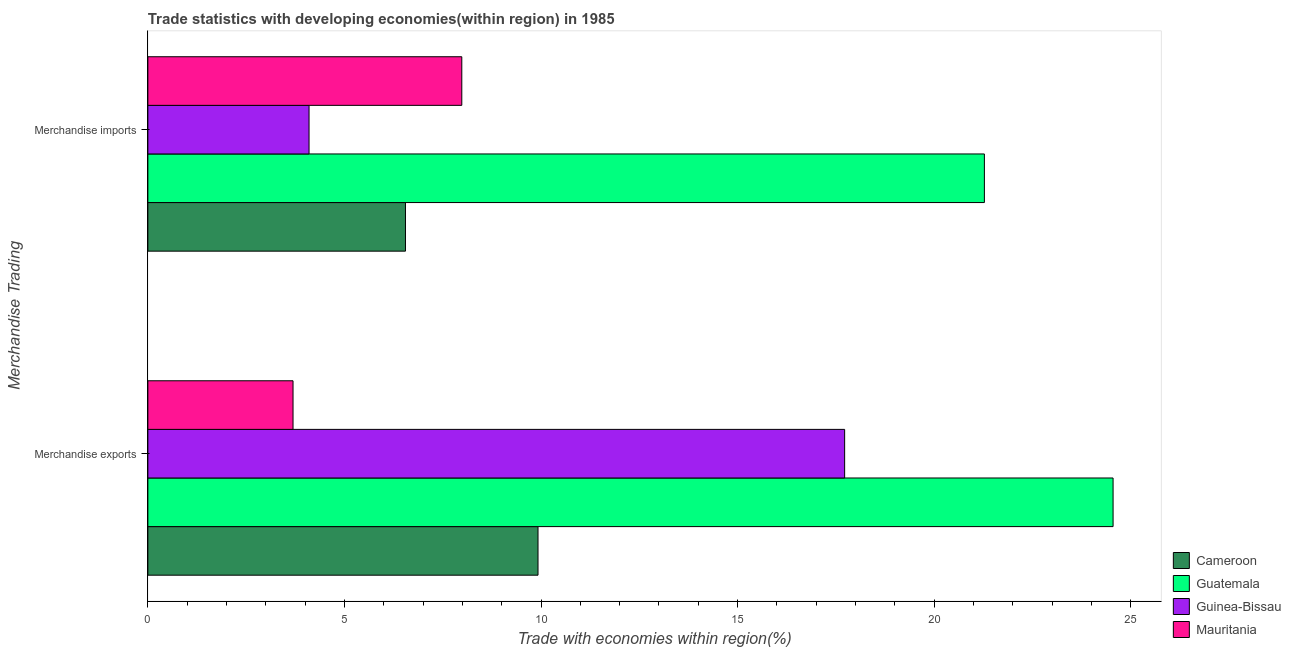How many different coloured bars are there?
Give a very brief answer. 4. How many groups of bars are there?
Your answer should be compact. 2. What is the label of the 1st group of bars from the top?
Make the answer very short. Merchandise imports. What is the merchandise imports in Mauritania?
Your answer should be very brief. 7.98. Across all countries, what is the maximum merchandise imports?
Keep it short and to the point. 21.28. Across all countries, what is the minimum merchandise exports?
Your answer should be compact. 3.69. In which country was the merchandise imports maximum?
Provide a short and direct response. Guatemala. In which country was the merchandise imports minimum?
Make the answer very short. Guinea-Bissau. What is the total merchandise imports in the graph?
Ensure brevity in your answer.  39.91. What is the difference between the merchandise imports in Cameroon and that in Guinea-Bissau?
Provide a succinct answer. 2.45. What is the difference between the merchandise imports in Mauritania and the merchandise exports in Guinea-Bissau?
Ensure brevity in your answer.  -9.74. What is the average merchandise imports per country?
Your answer should be very brief. 9.98. What is the difference between the merchandise exports and merchandise imports in Guinea-Bissau?
Keep it short and to the point. 13.62. In how many countries, is the merchandise imports greater than 13 %?
Ensure brevity in your answer.  1. What is the ratio of the merchandise exports in Guinea-Bissau to that in Guatemala?
Give a very brief answer. 0.72. In how many countries, is the merchandise imports greater than the average merchandise imports taken over all countries?
Your answer should be compact. 1. What does the 3rd bar from the top in Merchandise exports represents?
Give a very brief answer. Guatemala. What does the 2nd bar from the bottom in Merchandise exports represents?
Provide a short and direct response. Guatemala. How many bars are there?
Your answer should be very brief. 8. Are all the bars in the graph horizontal?
Give a very brief answer. Yes. What is the difference between two consecutive major ticks on the X-axis?
Your answer should be very brief. 5. Does the graph contain grids?
Make the answer very short. No. How many legend labels are there?
Offer a terse response. 4. How are the legend labels stacked?
Keep it short and to the point. Vertical. What is the title of the graph?
Offer a very short reply. Trade statistics with developing economies(within region) in 1985. Does "Malaysia" appear as one of the legend labels in the graph?
Keep it short and to the point. No. What is the label or title of the X-axis?
Provide a short and direct response. Trade with economies within region(%). What is the label or title of the Y-axis?
Offer a very short reply. Merchandise Trading. What is the Trade with economies within region(%) of Cameroon in Merchandise exports?
Provide a short and direct response. 9.92. What is the Trade with economies within region(%) of Guatemala in Merchandise exports?
Ensure brevity in your answer.  24.55. What is the Trade with economies within region(%) in Guinea-Bissau in Merchandise exports?
Ensure brevity in your answer.  17.72. What is the Trade with economies within region(%) of Mauritania in Merchandise exports?
Your answer should be compact. 3.69. What is the Trade with economies within region(%) in Cameroon in Merchandise imports?
Your answer should be compact. 6.55. What is the Trade with economies within region(%) of Guatemala in Merchandise imports?
Give a very brief answer. 21.28. What is the Trade with economies within region(%) in Guinea-Bissau in Merchandise imports?
Offer a terse response. 4.1. What is the Trade with economies within region(%) of Mauritania in Merchandise imports?
Give a very brief answer. 7.98. Across all Merchandise Trading, what is the maximum Trade with economies within region(%) of Cameroon?
Make the answer very short. 9.92. Across all Merchandise Trading, what is the maximum Trade with economies within region(%) of Guatemala?
Your answer should be very brief. 24.55. Across all Merchandise Trading, what is the maximum Trade with economies within region(%) in Guinea-Bissau?
Offer a very short reply. 17.72. Across all Merchandise Trading, what is the maximum Trade with economies within region(%) in Mauritania?
Provide a succinct answer. 7.98. Across all Merchandise Trading, what is the minimum Trade with economies within region(%) of Cameroon?
Your answer should be very brief. 6.55. Across all Merchandise Trading, what is the minimum Trade with economies within region(%) in Guatemala?
Make the answer very short. 21.28. Across all Merchandise Trading, what is the minimum Trade with economies within region(%) of Guinea-Bissau?
Offer a terse response. 4.1. Across all Merchandise Trading, what is the minimum Trade with economies within region(%) of Mauritania?
Your response must be concise. 3.69. What is the total Trade with economies within region(%) in Cameroon in the graph?
Offer a very short reply. 16.48. What is the total Trade with economies within region(%) of Guatemala in the graph?
Your answer should be very brief. 45.83. What is the total Trade with economies within region(%) of Guinea-Bissau in the graph?
Give a very brief answer. 21.82. What is the total Trade with economies within region(%) in Mauritania in the graph?
Your answer should be compact. 11.68. What is the difference between the Trade with economies within region(%) of Cameroon in Merchandise exports and that in Merchandise imports?
Offer a very short reply. 3.37. What is the difference between the Trade with economies within region(%) in Guatemala in Merchandise exports and that in Merchandise imports?
Give a very brief answer. 3.27. What is the difference between the Trade with economies within region(%) in Guinea-Bissau in Merchandise exports and that in Merchandise imports?
Make the answer very short. 13.62. What is the difference between the Trade with economies within region(%) in Mauritania in Merchandise exports and that in Merchandise imports?
Keep it short and to the point. -4.29. What is the difference between the Trade with economies within region(%) of Cameroon in Merchandise exports and the Trade with economies within region(%) of Guatemala in Merchandise imports?
Your response must be concise. -11.35. What is the difference between the Trade with economies within region(%) in Cameroon in Merchandise exports and the Trade with economies within region(%) in Guinea-Bissau in Merchandise imports?
Your answer should be very brief. 5.82. What is the difference between the Trade with economies within region(%) of Cameroon in Merchandise exports and the Trade with economies within region(%) of Mauritania in Merchandise imports?
Keep it short and to the point. 1.94. What is the difference between the Trade with economies within region(%) in Guatemala in Merchandise exports and the Trade with economies within region(%) in Guinea-Bissau in Merchandise imports?
Your answer should be compact. 20.45. What is the difference between the Trade with economies within region(%) in Guatemala in Merchandise exports and the Trade with economies within region(%) in Mauritania in Merchandise imports?
Give a very brief answer. 16.57. What is the difference between the Trade with economies within region(%) in Guinea-Bissau in Merchandise exports and the Trade with economies within region(%) in Mauritania in Merchandise imports?
Your response must be concise. 9.74. What is the average Trade with economies within region(%) of Cameroon per Merchandise Trading?
Give a very brief answer. 8.24. What is the average Trade with economies within region(%) in Guatemala per Merchandise Trading?
Offer a terse response. 22.91. What is the average Trade with economies within region(%) in Guinea-Bissau per Merchandise Trading?
Give a very brief answer. 10.91. What is the average Trade with economies within region(%) in Mauritania per Merchandise Trading?
Offer a very short reply. 5.84. What is the difference between the Trade with economies within region(%) of Cameroon and Trade with economies within region(%) of Guatemala in Merchandise exports?
Your answer should be compact. -14.63. What is the difference between the Trade with economies within region(%) in Cameroon and Trade with economies within region(%) in Guinea-Bissau in Merchandise exports?
Your response must be concise. -7.8. What is the difference between the Trade with economies within region(%) of Cameroon and Trade with economies within region(%) of Mauritania in Merchandise exports?
Your answer should be compact. 6.23. What is the difference between the Trade with economies within region(%) in Guatemala and Trade with economies within region(%) in Guinea-Bissau in Merchandise exports?
Make the answer very short. 6.83. What is the difference between the Trade with economies within region(%) in Guatemala and Trade with economies within region(%) in Mauritania in Merchandise exports?
Your answer should be very brief. 20.86. What is the difference between the Trade with economies within region(%) of Guinea-Bissau and Trade with economies within region(%) of Mauritania in Merchandise exports?
Give a very brief answer. 14.03. What is the difference between the Trade with economies within region(%) of Cameroon and Trade with economies within region(%) of Guatemala in Merchandise imports?
Keep it short and to the point. -14.73. What is the difference between the Trade with economies within region(%) of Cameroon and Trade with economies within region(%) of Guinea-Bissau in Merchandise imports?
Ensure brevity in your answer.  2.45. What is the difference between the Trade with economies within region(%) in Cameroon and Trade with economies within region(%) in Mauritania in Merchandise imports?
Ensure brevity in your answer.  -1.43. What is the difference between the Trade with economies within region(%) of Guatemala and Trade with economies within region(%) of Guinea-Bissau in Merchandise imports?
Provide a succinct answer. 17.18. What is the difference between the Trade with economies within region(%) in Guatemala and Trade with economies within region(%) in Mauritania in Merchandise imports?
Your response must be concise. 13.29. What is the difference between the Trade with economies within region(%) in Guinea-Bissau and Trade with economies within region(%) in Mauritania in Merchandise imports?
Make the answer very short. -3.89. What is the ratio of the Trade with economies within region(%) in Cameroon in Merchandise exports to that in Merchandise imports?
Give a very brief answer. 1.51. What is the ratio of the Trade with economies within region(%) in Guatemala in Merchandise exports to that in Merchandise imports?
Ensure brevity in your answer.  1.15. What is the ratio of the Trade with economies within region(%) in Guinea-Bissau in Merchandise exports to that in Merchandise imports?
Keep it short and to the point. 4.32. What is the ratio of the Trade with economies within region(%) in Mauritania in Merchandise exports to that in Merchandise imports?
Give a very brief answer. 0.46. What is the difference between the highest and the second highest Trade with economies within region(%) in Cameroon?
Ensure brevity in your answer.  3.37. What is the difference between the highest and the second highest Trade with economies within region(%) of Guatemala?
Provide a short and direct response. 3.27. What is the difference between the highest and the second highest Trade with economies within region(%) of Guinea-Bissau?
Your answer should be compact. 13.62. What is the difference between the highest and the second highest Trade with economies within region(%) in Mauritania?
Offer a very short reply. 4.29. What is the difference between the highest and the lowest Trade with economies within region(%) of Cameroon?
Provide a short and direct response. 3.37. What is the difference between the highest and the lowest Trade with economies within region(%) of Guatemala?
Offer a terse response. 3.27. What is the difference between the highest and the lowest Trade with economies within region(%) in Guinea-Bissau?
Give a very brief answer. 13.62. What is the difference between the highest and the lowest Trade with economies within region(%) of Mauritania?
Make the answer very short. 4.29. 